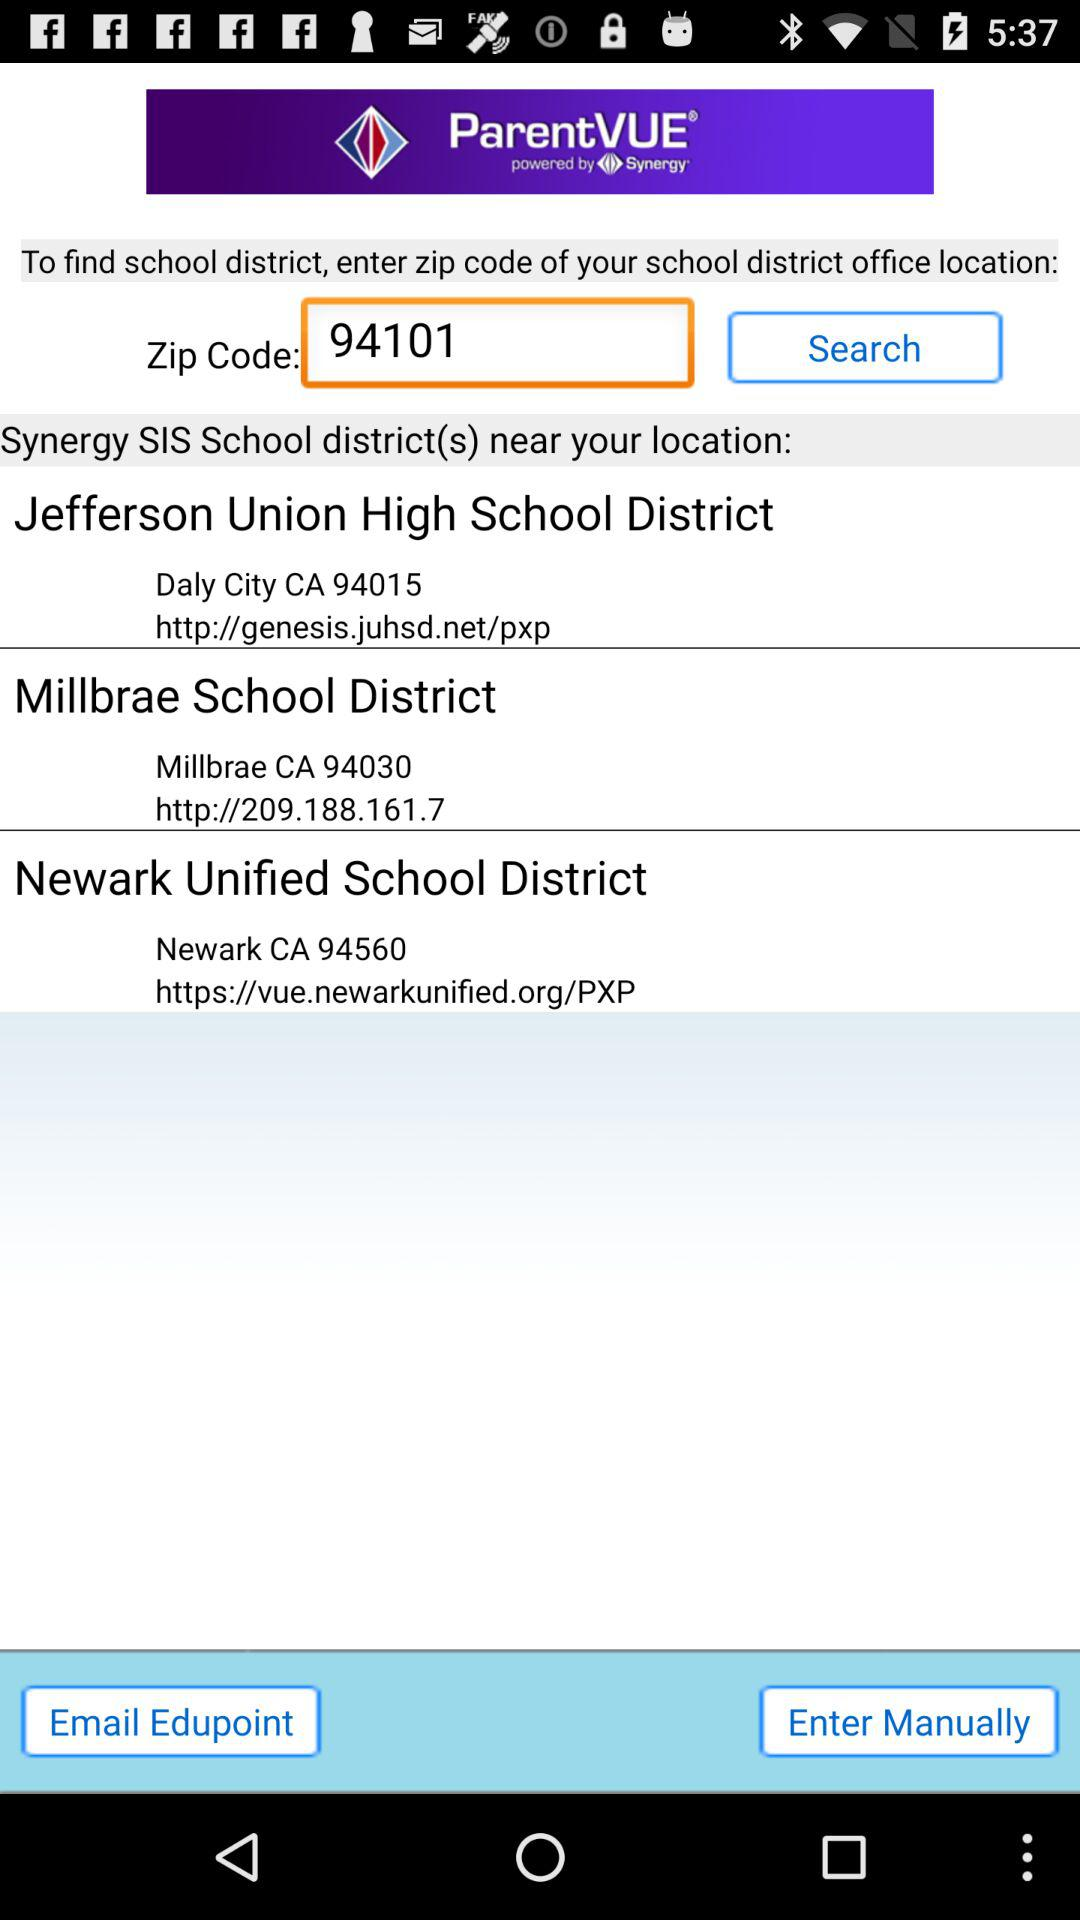What is the web address of the Jefferson Union high school? The web address of Jefferson Union High School is http://genesis.juhsd.net/pxp. 